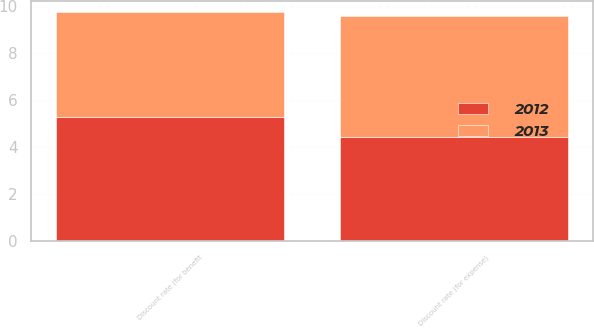Convert chart. <chart><loc_0><loc_0><loc_500><loc_500><stacked_bar_chart><ecel><fcel>Discount rate (for expense)<fcel>Discount rate (for benefit<nl><fcel>2012<fcel>4.45<fcel>5.3<nl><fcel>2013<fcel>5.15<fcel>4.45<nl></chart> 